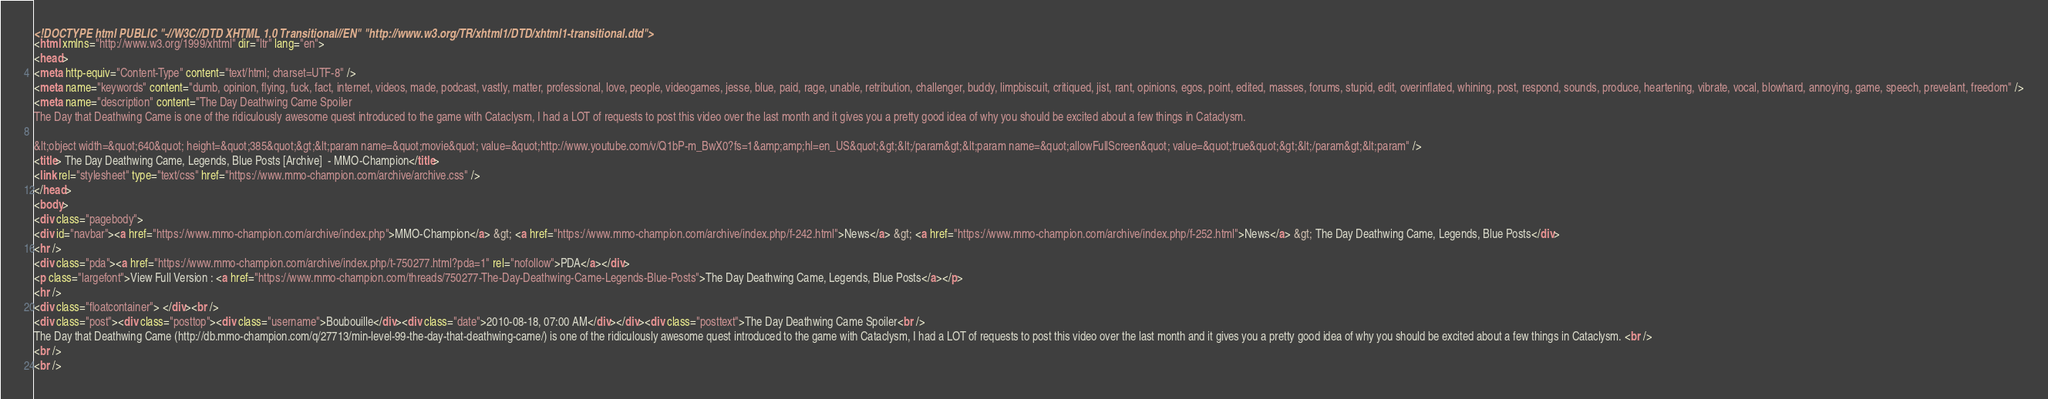<code> <loc_0><loc_0><loc_500><loc_500><_HTML_><!DOCTYPE html PUBLIC "-//W3C//DTD XHTML 1.0 Transitional//EN" "http://www.w3.org/TR/xhtml1/DTD/xhtml1-transitional.dtd">
<html xmlns="http://www.w3.org/1999/xhtml" dir="ltr" lang="en">
<head>
<meta http-equiv="Content-Type" content="text/html; charset=UTF-8" />
<meta name="keywords" content="dumb, opinion, flying, fuck, fact, internet, videos, made, podcast, vastly, matter, professional, love, people, videogames, jesse, blue, paid, rage, unable, retribution, challenger, buddy, limpbiscuit, critiqued, jist, rant, opinions, egos, point, edited, masses, forums, stupid, edit, overinflated, whining, post, respond, sounds, produce, heartening, vibrate, vocal, blowhard, annoying, game, speech, prevelant, freedom" />
<meta name="description" content="The Day Deathwing Came Spoiler 
The Day that Deathwing Came is one of the ridiculously awesome quest introduced to the game with Cataclysm, I had a LOT of requests to post this video over the last month and it gives you a pretty good idea of why you should be excited about a few things in Cataclysm.  
 
&lt;object width=&quot;640&quot; height=&quot;385&quot;&gt;&lt;param name=&quot;movie&quot; value=&quot;http://www.youtube.com/v/Q1bP-m_BwX0?fs=1&amp;amp;hl=en_US&quot;&gt;&lt;/param&gt;&lt;param name=&quot;allowFullScreen&quot; value=&quot;true&quot;&gt;&lt;/param&gt;&lt;param" />
<title> The Day Deathwing Came, Legends, Blue Posts [Archive]  - MMO-Champion</title>
<link rel="stylesheet" type="text/css" href="https://www.mmo-champion.com/archive/archive.css" />
</head>
<body>
<div class="pagebody">
<div id="navbar"><a href="https://www.mmo-champion.com/archive/index.php">MMO-Champion</a> &gt; <a href="https://www.mmo-champion.com/archive/index.php/f-242.html">News</a> &gt; <a href="https://www.mmo-champion.com/archive/index.php/f-252.html">News</a> &gt; The Day Deathwing Came, Legends, Blue Posts</div>
<hr />
<div class="pda"><a href="https://www.mmo-champion.com/archive/index.php/t-750277.html?pda=1" rel="nofollow">PDA</a></div>
<p class="largefont">View Full Version : <a href="https://www.mmo-champion.com/threads/750277-The-Day-Deathwing-Came-Legends-Blue-Posts">The Day Deathwing Came, Legends, Blue Posts</a></p>
<hr />
<div class="floatcontainer"> </div><br />
<div class="post"><div class="posttop"><div class="username">Boubouille</div><div class="date">2010-08-18, 07:00 AM</div></div><div class="posttext">The Day Deathwing Came Spoiler<br />
The Day that Deathwing Came (http://db.mmo-champion.com/q/27713/min-level-99-the-day-that-deathwing-came/) is one of the ridiculously awesome quest introduced to the game with Cataclysm, I had a LOT of requests to post this video over the last month and it gives you a pretty good idea of why you should be excited about a few things in Cataclysm. <br />
<br />
<br /></code> 